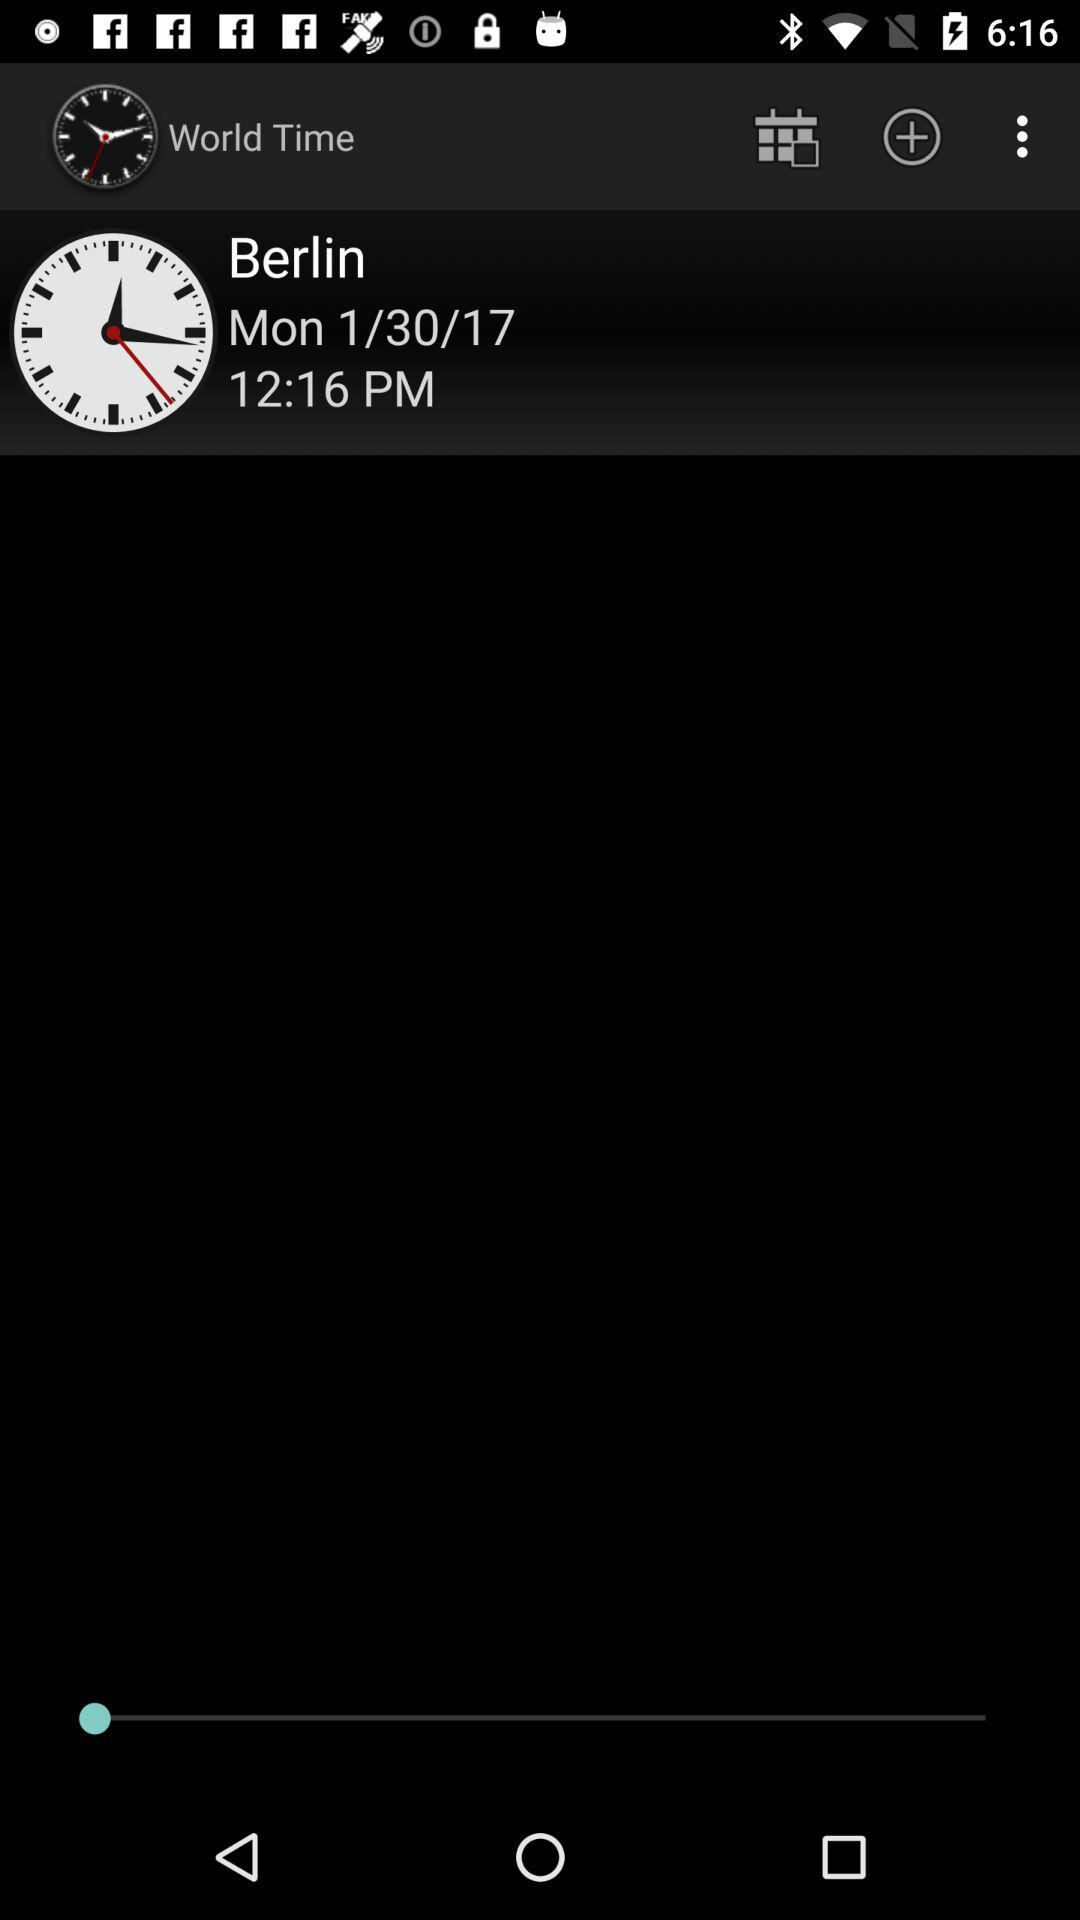What is the date shown on the screen? The date shown on the screen is Monday, January 30, 2017. 